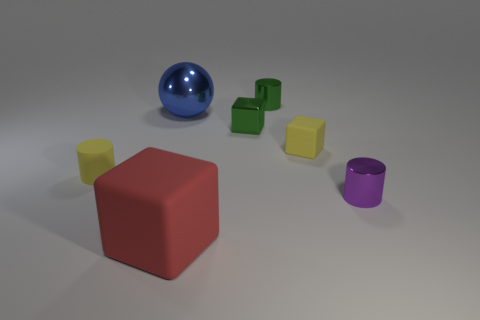Subtract all shiny cylinders. How many cylinders are left? 1 Add 1 spheres. How many objects exist? 8 Subtract 1 cylinders. How many cylinders are left? 2 Subtract all purple cylinders. How many cylinders are left? 2 Subtract all spheres. How many objects are left? 6 Subtract all purple cylinders. How many purple cubes are left? 0 Add 1 small yellow objects. How many small yellow objects are left? 3 Add 7 red matte objects. How many red matte objects exist? 8 Subtract 0 brown spheres. How many objects are left? 7 Subtract all cyan cylinders. Subtract all blue balls. How many cylinders are left? 3 